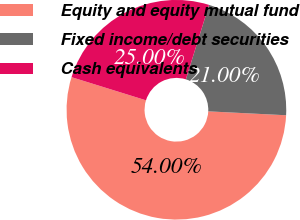Convert chart. <chart><loc_0><loc_0><loc_500><loc_500><pie_chart><fcel>Equity and equity mutual fund<fcel>Fixed income/debt securities<fcel>Cash equivalents<nl><fcel>54.0%<fcel>21.0%<fcel>25.0%<nl></chart> 